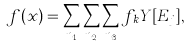<formula> <loc_0><loc_0><loc_500><loc_500>f ( x ) = \sum _ { n _ { 1 } } \sum _ { n _ { 2 } } \sum _ { n _ { 3 } } f _ { \, k } Y [ E _ { j } ] ,</formula> 